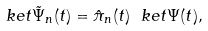Convert formula to latex. <formula><loc_0><loc_0><loc_500><loc_500>\ k e t { \tilde { \Psi } _ { n } ( t ) } = { \hat { \pi } _ { n } ( t ) \ k e t { \Psi ( t ) } } ,</formula> 